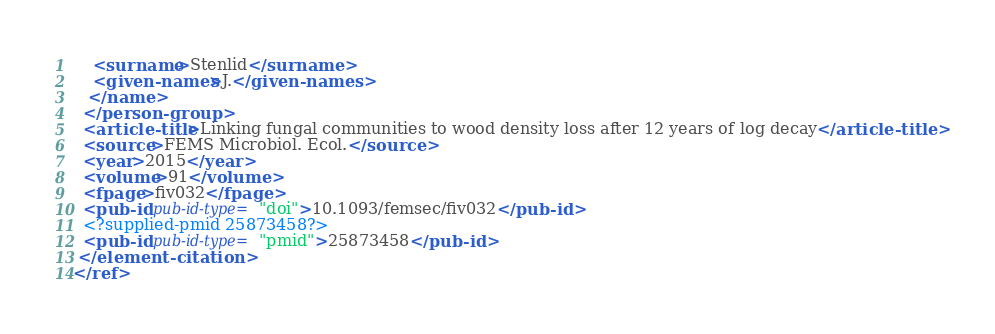<code> <loc_0><loc_0><loc_500><loc_500><_XML_>    <surname>Stenlid</surname>
    <given-names>J.</given-names>
   </name>
  </person-group>
  <article-title>Linking fungal communities to wood density loss after 12 years of log decay</article-title>
  <source>FEMS Microbiol. Ecol.</source>
  <year>2015</year>
  <volume>91</volume>
  <fpage>fiv032</fpage>
  <pub-id pub-id-type="doi">10.1093/femsec/fiv032</pub-id>
  <?supplied-pmid 25873458?>
  <pub-id pub-id-type="pmid">25873458</pub-id>
 </element-citation>
</ref>
</code> 